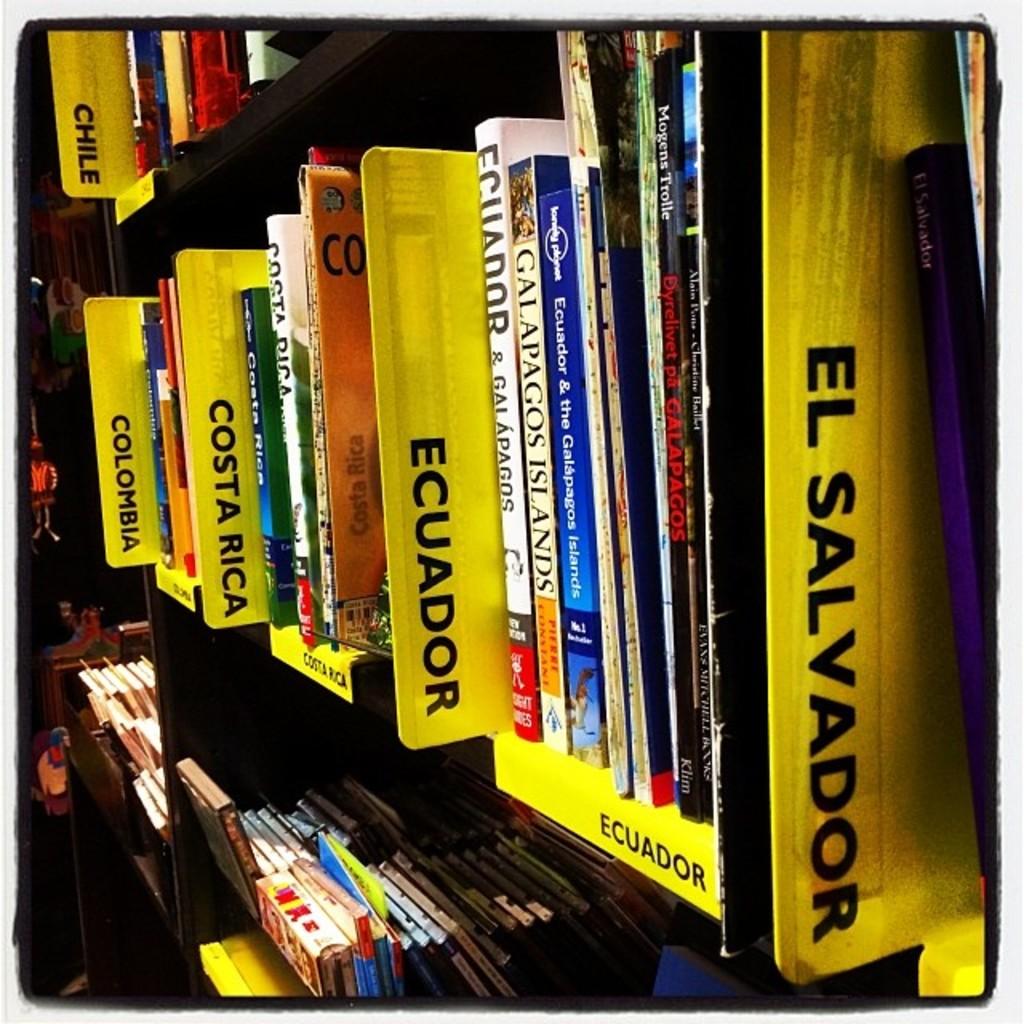What section is closest to you?
Offer a very short reply. El salvador. 